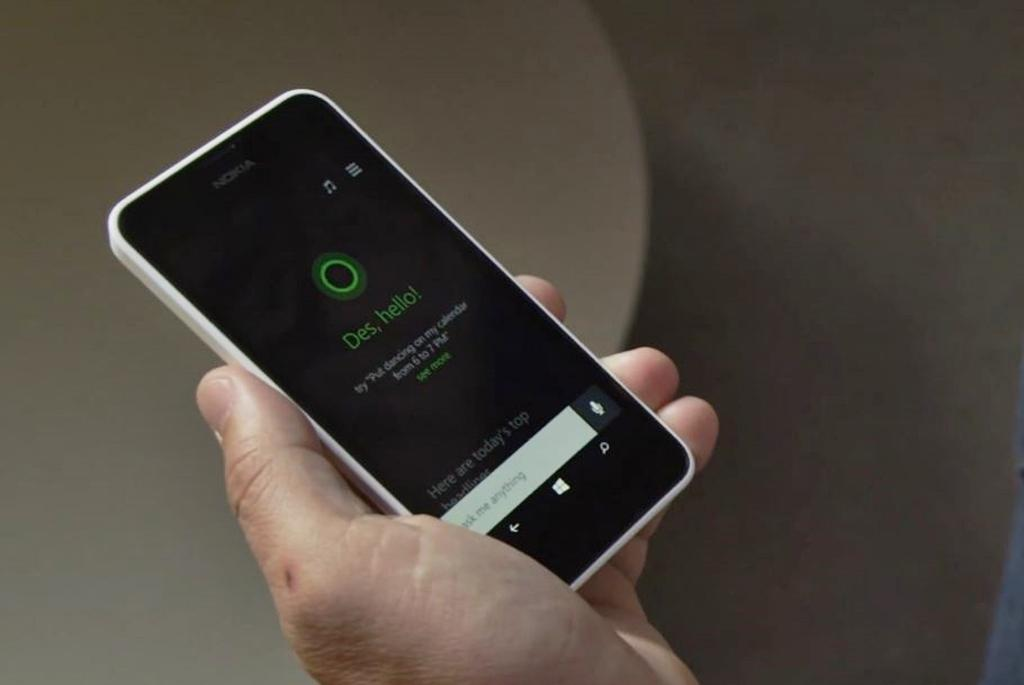Provide a one-sentence caption for the provided image. A phone with cortana on it that says Des, hello. 